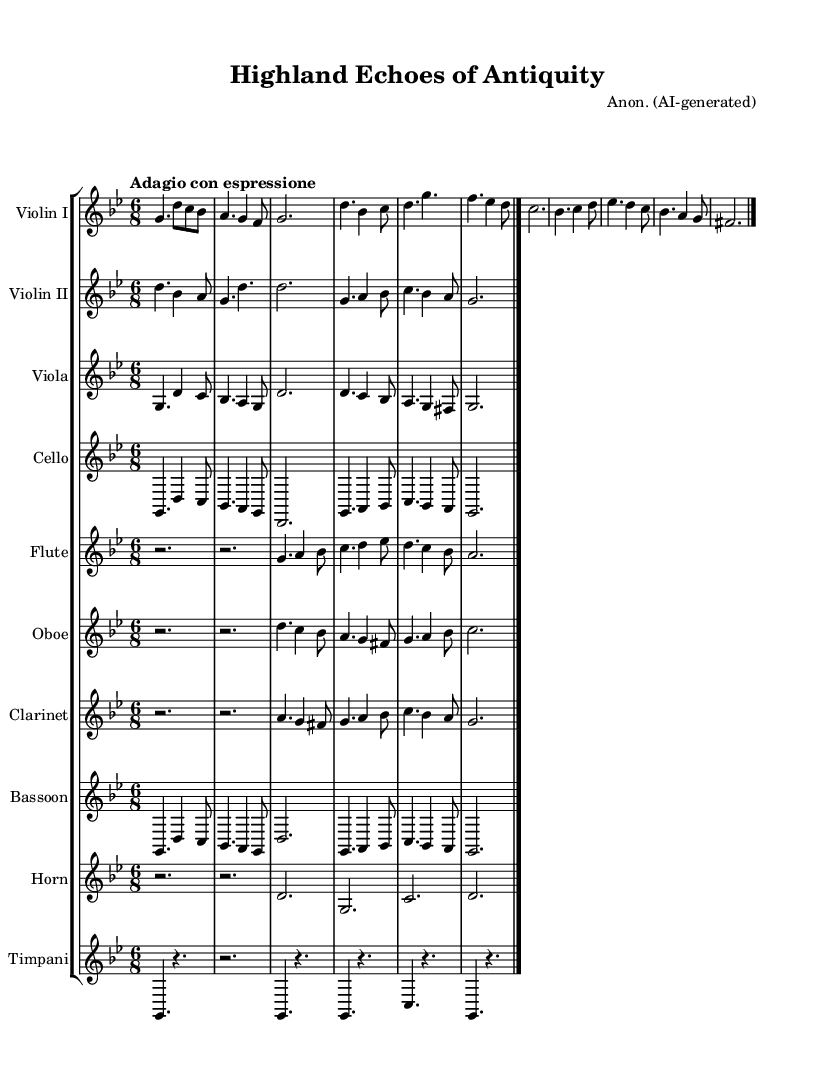What is the key signature of this music? The key signature is G minor, which is indicated by two flats in the key signature.
Answer: G minor What is the time signature of the piece? The time signature is 6/8, which means there are six eighth notes per measure.
Answer: 6/8 What is the tempo marking for the music? The tempo marking is "Adagio con espressione," indicating a slow pace with expression.
Answer: Adagio con espressione Which instruments are included in this orchestral piece? The piece includes Violin I, Violin II, Viola, Cello, Flute, Oboe, Clarinet, Bassoon, Horn, and Timpani, as shown by the staff headings.
Answer: Violin I, Violin II, Viola, Cello, Flute, Oboe, Clarinet, Bassoon, Horn, Timpani Identify the thematic sections of the music. The music presents Theme A and Theme B, as denoted in the score annotations.
Answer: Theme A and Theme B What characteristic of Romantic music is represented in this piece? The piece illustrates expressiveness and emotional depth, typical of Romantic orchestral compositions, as seen in the tempo marking and thematic development.
Answer: Expressiveness What role does the timpani play in this orchestral work? The Timpani provides rhythmic support and highlights key moments in the music, as indicated by its rhythmic figures in the score.
Answer: Rhythmic support 